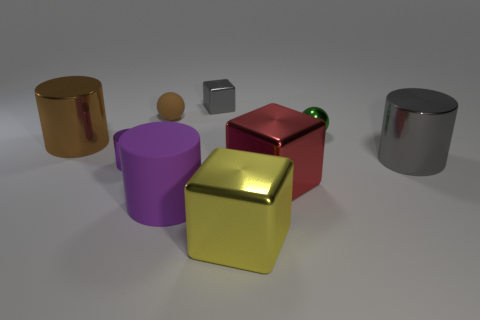What textures are visible on the objects, and how do they differ from one another? The objects display a fascinating array of textures: the golden and silver cylinders exhibit a reflective, polished metal sheen, while the red and yellow cubes seem somewhat matte, yet still with a subtle shine. The tiny metallic cube resembles brushed steel with its understated luster, and the small wooden sphere has a natural, grainy texture. The interplay of light on these surfaces creates a compelling contrast, imparting each object with its own tactile identity. 